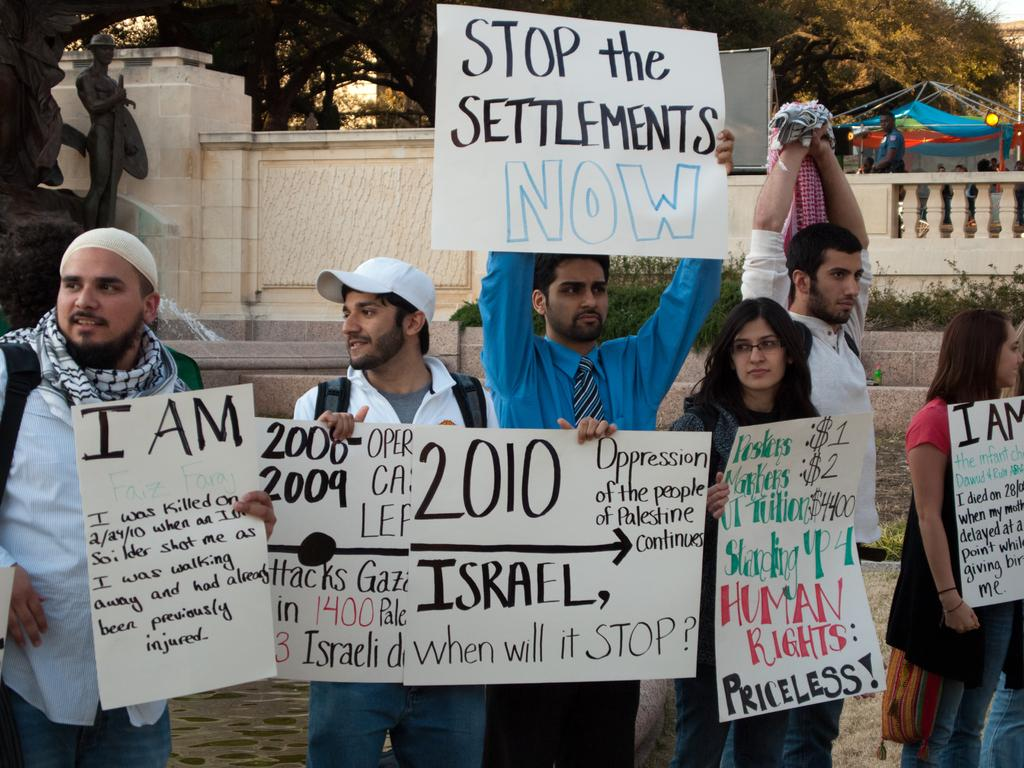What are the persons in the image doing? The persons in the image are standing and holding a white sheet. What is on the white sheet? There is writing on the white sheet. What can be seen in the background of the image? There are trees in the background of the image. What type of coat is the person wearing in the image? There is no coat visible in the image; the persons are holding a white sheet. What is the purpose of the protest in the image? There is no protest present in the image; the persons are holding a white sheet with writing on it. 